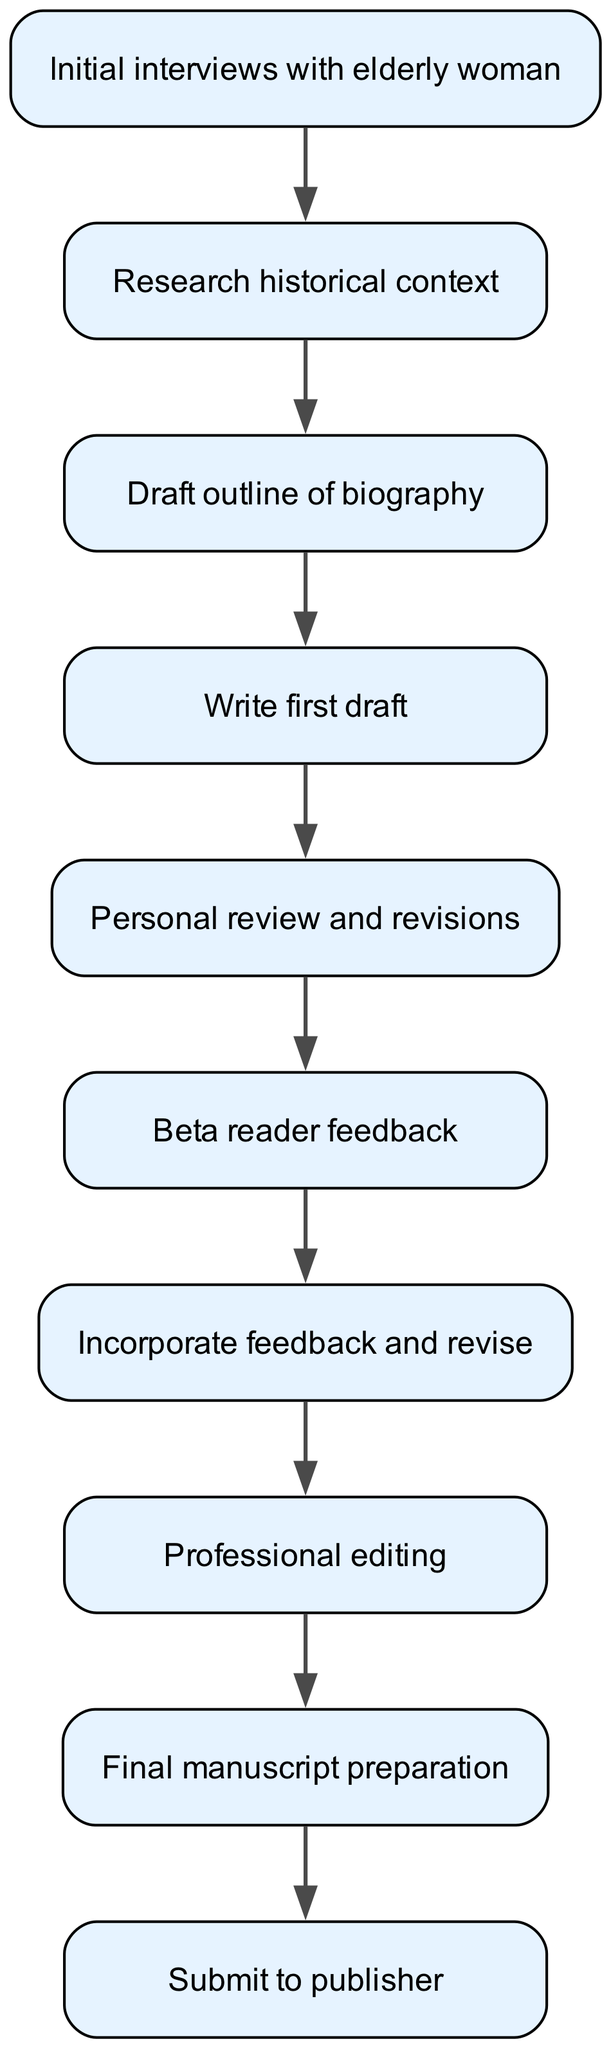What is the first step in the workflow? The workflow starts with "Initial interviews with elderly woman," which is the first node in the diagram.
Answer: Initial interviews with elderly woman How many nodes are there in the diagram? There are ten nodes in total, each representing a step in the writing and revision workflow.
Answer: Ten What is the final step before submission to the publisher? The node preceding "Submit to publisher" is "Final manuscript preparation," indicating that this is the final step before submission.
Answer: Final manuscript preparation Which step follows "Write first draft"? The next step after "Write first draft" is "Personal review and revisions," as indicated by the directional connection in the diagram.
Answer: Personal review and revisions What type of feedback is gathered after the personal review? After the personal review, "Beta reader feedback" is collected, which is the direct subsequent step in the process.
Answer: Beta reader feedback How does "Incorporate feedback and revise" relate to "Professional editing"? "Incorporate feedback and revise" directly leads to "Professional editing," indicating that revisions based on feedback must occur before professional editing can start.
Answer: Incorporate feedback and revise leads to Professional editing What step occurs after researching historical context? Following "Research historical context" is "Draft outline of biography," indicating that outlining happens after the research phase.
Answer: Draft outline of biography How many steps are there between the initial interviews and the final manuscript? There are eight steps from "Initial interviews with elderly woman" to "Final manuscript preparation," moving through the workflow sequentially.
Answer: Eight steps What connects the "Beta reader feedback" and "Incorporate feedback and revise"? The "Beta reader feedback" directly leads to "Incorporate feedback and revise," establishing a clear connection between receiving feedback and making revisions.
Answer: Beta reader feedback leads to Incorporate feedback and revise 